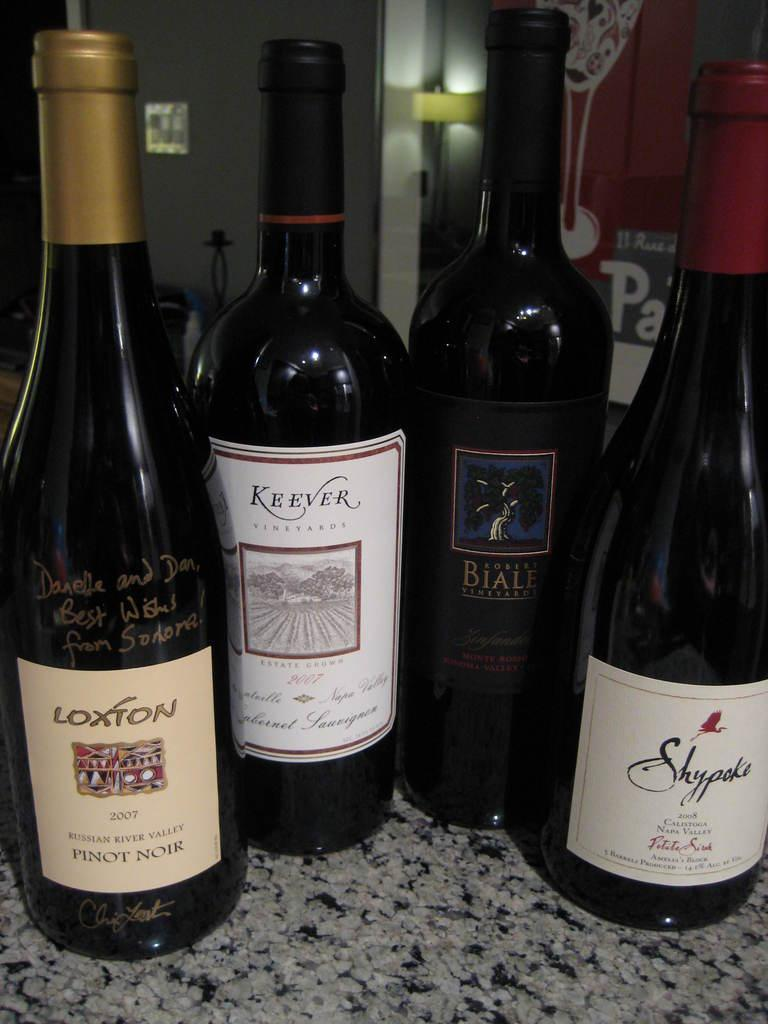Provide a one-sentence caption for the provided image. A bottle of Loxton 2007 Russian River Valley Pinot Noir sits on a counter with a bottle of Keever 2007 Cabernet Sauvignon and 2 others. 